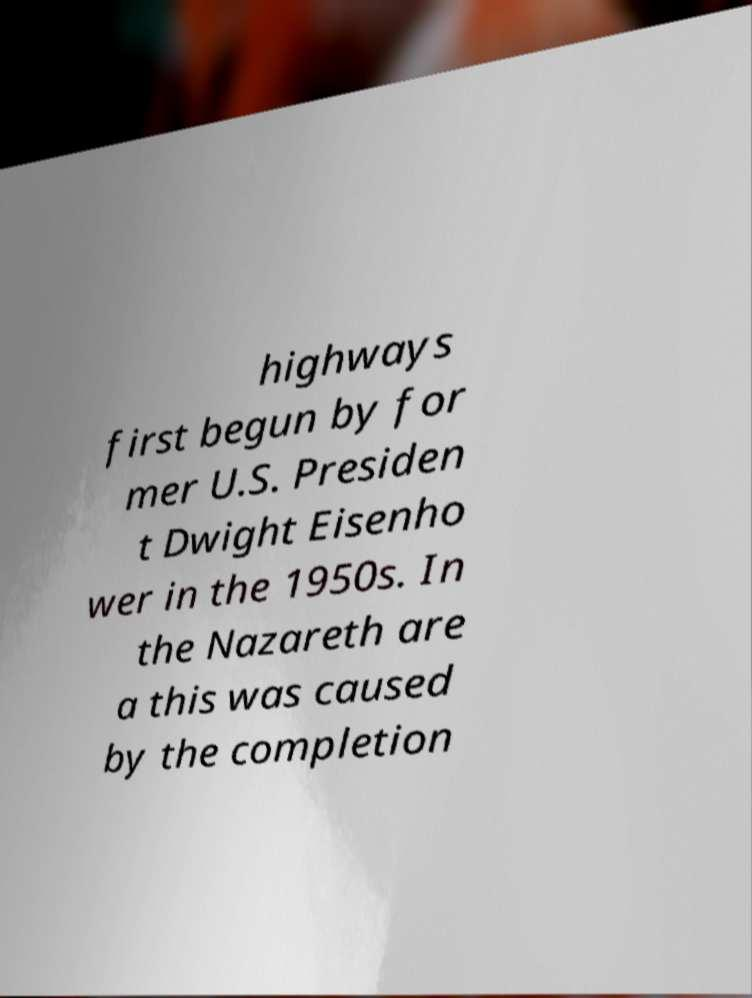I need the written content from this picture converted into text. Can you do that? highways first begun by for mer U.S. Presiden t Dwight Eisenho wer in the 1950s. In the Nazareth are a this was caused by the completion 